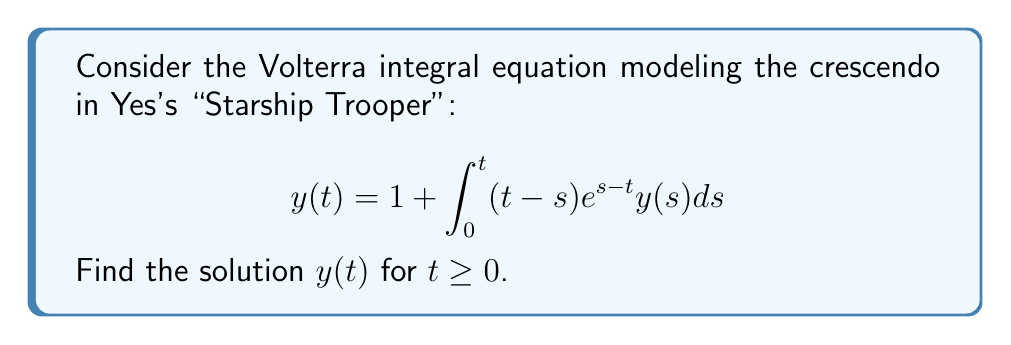Teach me how to tackle this problem. Let's solve this step-by-step:

1) First, we recognize this as a Volterra integral equation of the second kind.

2) We'll use the method of successive approximations (Picard iteration).

3) Let $y_0(t) = 1$ be our initial approximation.

4) For the first iteration:
   $$y_1(t) = 1 + \int_0^t (t-s)e^{s-t} \cdot 1 ds$$

5) Evaluate the integral:
   $$y_1(t) = 1 + \int_0^t (t-s)e^{s-t} ds = 1 + [-(t-s)e^{s-t} - e^{s-t}]_0^t = 1 + t$$

6) For the second iteration:
   $$y_2(t) = 1 + \int_0^t (t-s)e^{s-t} \cdot (1+s) ds$$

7) Evaluate this integral:
   $$y_2(t) = 1 + \int_0^t (t-s)e^{s-t} ds + \int_0^t (t-s)se^{s-t} ds$$
   $$= (1+t) + [-(t-s)se^{s-t} - 2se^{s-t} - 2e^{s-t}]_0^t = 1 + t + \frac{t^2}{2}$$

8) Continuing this process, we can see a pattern emerging:
   $$y_3(t) = 1 + t + \frac{t^2}{2} + \frac{t^3}{3!}$$
   $$y_4(t) = 1 + t + \frac{t^2}{2} + \frac{t^3}{3!} + \frac{t^4}{4!}$$

9) We can conjecture that the solution is:
   $$y(t) = 1 + t + \frac{t^2}{2!} + \frac{t^3}{3!} + \frac{t^4}{4!} + ... = e^t$$

10) Verify this solution by substituting it back into the original equation:
    $$e^t = 1 + \int_0^t (t-s)e^{s-t}e^s ds = 1 + \int_0^t (t-s) ds = 1 + [\frac{t^2}{2} - \frac{s^2}{2}]_0^t = 1 + \frac{t^2}{2}$$

    This equals $e^t$ when expanded as a Taylor series, confirming our solution.
Answer: $y(t) = e^t$ 